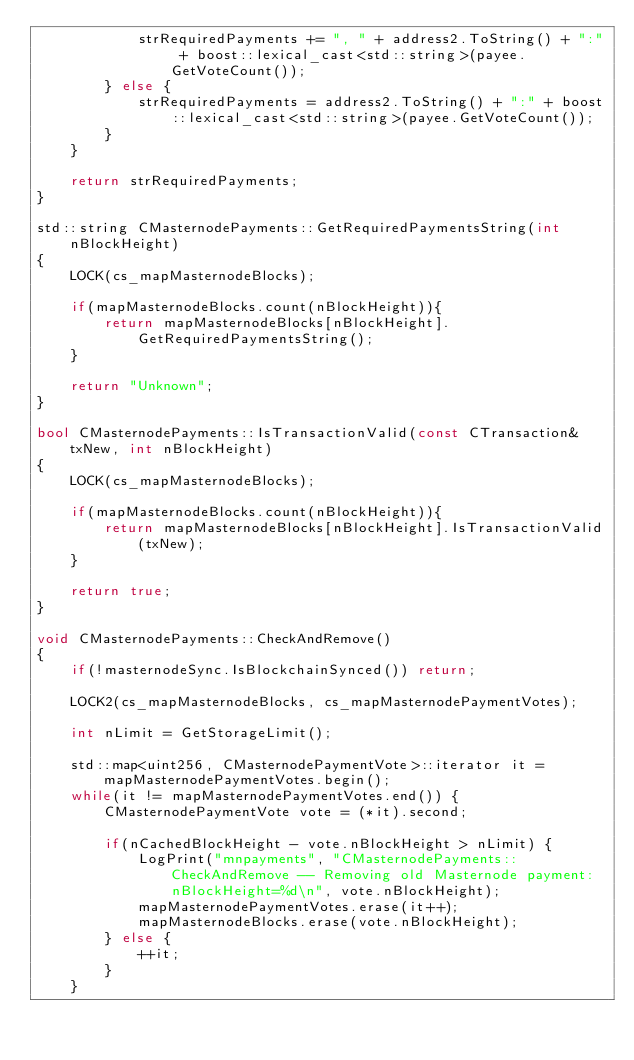Convert code to text. <code><loc_0><loc_0><loc_500><loc_500><_C++_>            strRequiredPayments += ", " + address2.ToString() + ":" + boost::lexical_cast<std::string>(payee.GetVoteCount());
        } else {
            strRequiredPayments = address2.ToString() + ":" + boost::lexical_cast<std::string>(payee.GetVoteCount());
        }
    }

    return strRequiredPayments;
}

std::string CMasternodePayments::GetRequiredPaymentsString(int nBlockHeight)
{
    LOCK(cs_mapMasternodeBlocks);

    if(mapMasternodeBlocks.count(nBlockHeight)){
        return mapMasternodeBlocks[nBlockHeight].GetRequiredPaymentsString();
    }

    return "Unknown";
}

bool CMasternodePayments::IsTransactionValid(const CTransaction& txNew, int nBlockHeight)
{
    LOCK(cs_mapMasternodeBlocks);

    if(mapMasternodeBlocks.count(nBlockHeight)){
        return mapMasternodeBlocks[nBlockHeight].IsTransactionValid(txNew);
    }

    return true;
}

void CMasternodePayments::CheckAndRemove()
{
    if(!masternodeSync.IsBlockchainSynced()) return;

    LOCK2(cs_mapMasternodeBlocks, cs_mapMasternodePaymentVotes);

    int nLimit = GetStorageLimit();

    std::map<uint256, CMasternodePaymentVote>::iterator it = mapMasternodePaymentVotes.begin();
    while(it != mapMasternodePaymentVotes.end()) {
        CMasternodePaymentVote vote = (*it).second;

        if(nCachedBlockHeight - vote.nBlockHeight > nLimit) {
            LogPrint("mnpayments", "CMasternodePayments::CheckAndRemove -- Removing old Masternode payment: nBlockHeight=%d\n", vote.nBlockHeight);
            mapMasternodePaymentVotes.erase(it++);
            mapMasternodeBlocks.erase(vote.nBlockHeight);
        } else {
            ++it;
        }
    }</code> 